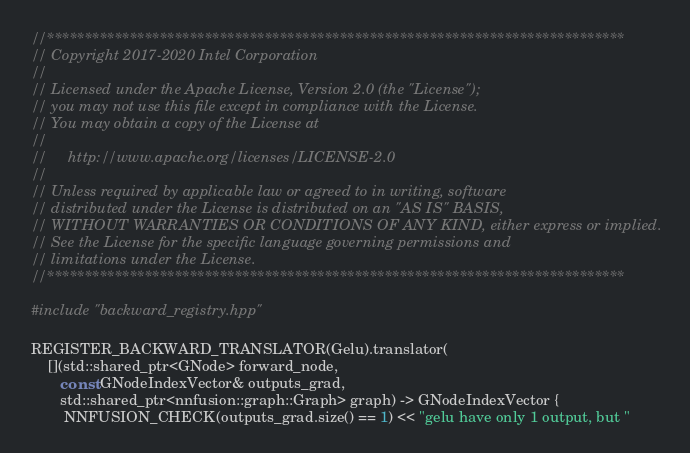<code> <loc_0><loc_0><loc_500><loc_500><_C++_>//*****************************************************************************
// Copyright 2017-2020 Intel Corporation
//
// Licensed under the Apache License, Version 2.0 (the "License");
// you may not use this file except in compliance with the License.
// You may obtain a copy of the License at
//
//     http://www.apache.org/licenses/LICENSE-2.0
//
// Unless required by applicable law or agreed to in writing, software
// distributed under the License is distributed on an "AS IS" BASIS,
// WITHOUT WARRANTIES OR CONDITIONS OF ANY KIND, either express or implied.
// See the License for the specific language governing permissions and
// limitations under the License.
//*****************************************************************************

#include "backward_registry.hpp"

REGISTER_BACKWARD_TRANSLATOR(Gelu).translator(
    [](std::shared_ptr<GNode> forward_node,
       const GNodeIndexVector& outputs_grad,
       std::shared_ptr<nnfusion::graph::Graph> graph) -> GNodeIndexVector {
        NNFUSION_CHECK(outputs_grad.size() == 1) << "gelu have only 1 output, but "</code> 